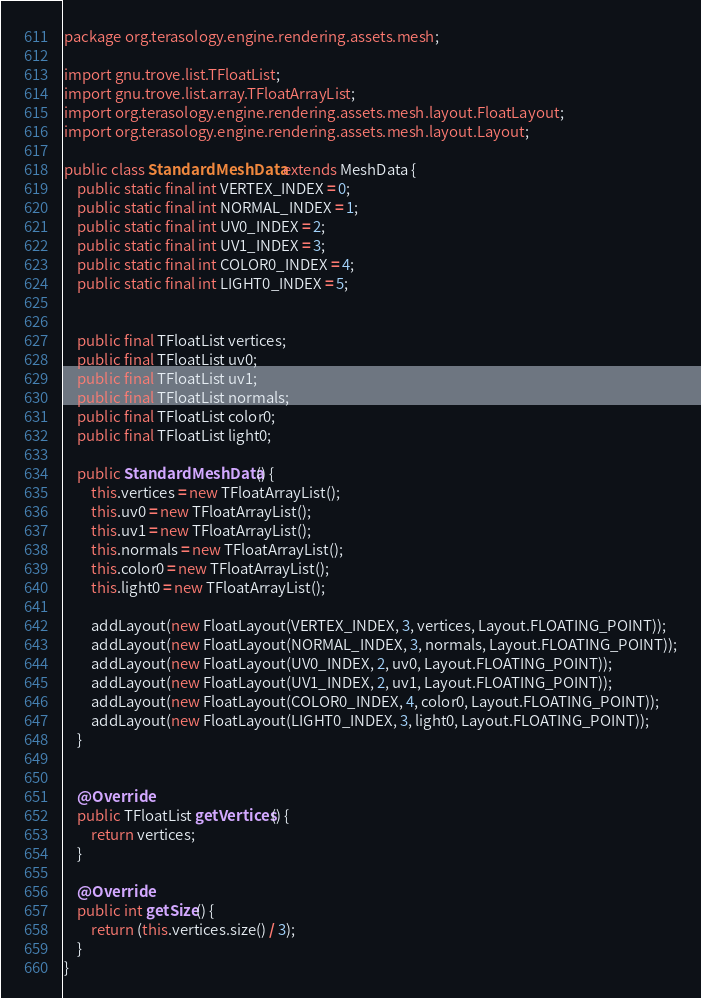<code> <loc_0><loc_0><loc_500><loc_500><_Java_>package org.terasology.engine.rendering.assets.mesh;

import gnu.trove.list.TFloatList;
import gnu.trove.list.array.TFloatArrayList;
import org.terasology.engine.rendering.assets.mesh.layout.FloatLayout;
import org.terasology.engine.rendering.assets.mesh.layout.Layout;

public class StandardMeshData extends MeshData {
    public static final int VERTEX_INDEX = 0;
    public static final int NORMAL_INDEX = 1;
    public static final int UV0_INDEX = 2;
    public static final int UV1_INDEX = 3;
    public static final int COLOR0_INDEX = 4;
    public static final int LIGHT0_INDEX = 5;


    public final TFloatList vertices;
    public final TFloatList uv0;
    public final TFloatList uv1;
    public final TFloatList normals;
    public final TFloatList color0;
    public final TFloatList light0;

    public StandardMeshData() {
        this.vertices = new TFloatArrayList();
        this.uv0 = new TFloatArrayList();
        this.uv1 = new TFloatArrayList();
        this.normals = new TFloatArrayList();
        this.color0 = new TFloatArrayList();
        this.light0 = new TFloatArrayList();

        addLayout(new FloatLayout(VERTEX_INDEX, 3, vertices, Layout.FLOATING_POINT));
        addLayout(new FloatLayout(NORMAL_INDEX, 3, normals, Layout.FLOATING_POINT));
        addLayout(new FloatLayout(UV0_INDEX, 2, uv0, Layout.FLOATING_POINT));
        addLayout(new FloatLayout(UV1_INDEX, 2, uv1, Layout.FLOATING_POINT));
        addLayout(new FloatLayout(COLOR0_INDEX, 4, color0, Layout.FLOATING_POINT));
        addLayout(new FloatLayout(LIGHT0_INDEX, 3, light0, Layout.FLOATING_POINT));
    }


    @Override
    public TFloatList getVertices() {
        return vertices;
    }

    @Override
    public int getSize() {
        return (this.vertices.size() / 3);
    }
}
</code> 